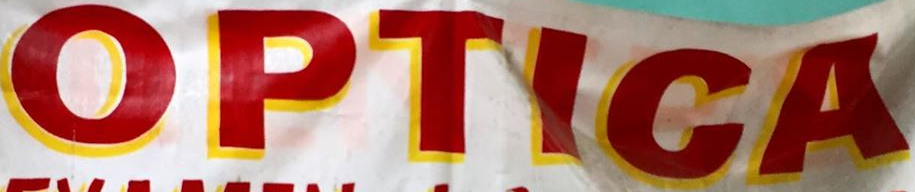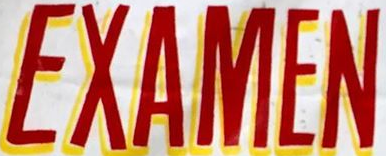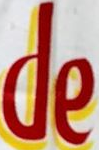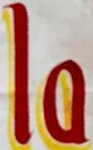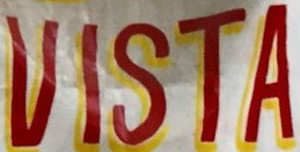What words can you see in these images in sequence, separated by a semicolon? OPTICA; EXAMEN; de; la; VISTA 